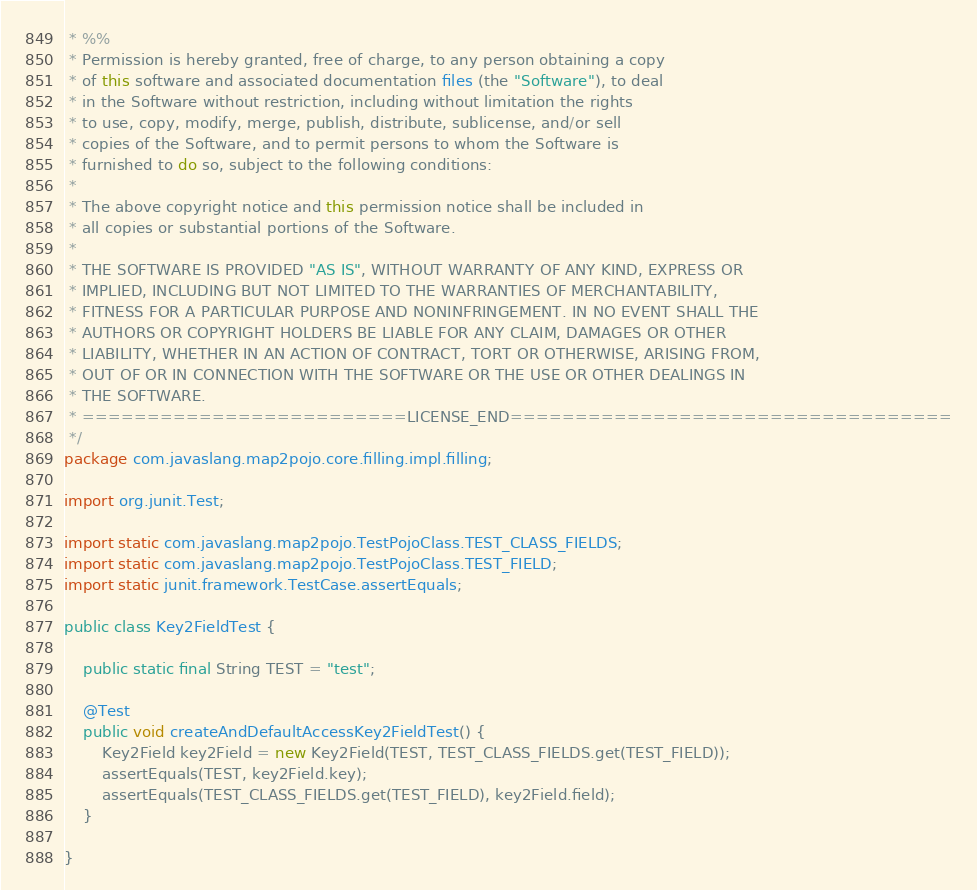Convert code to text. <code><loc_0><loc_0><loc_500><loc_500><_Java_> * %%
 * Permission is hereby granted, free of charge, to any person obtaining a copy
 * of this software and associated documentation files (the "Software"), to deal
 * in the Software without restriction, including without limitation the rights
 * to use, copy, modify, merge, publish, distribute, sublicense, and/or sell
 * copies of the Software, and to permit persons to whom the Software is
 * furnished to do so, subject to the following conditions:
 *
 * The above copyright notice and this permission notice shall be included in
 * all copies or substantial portions of the Software.
 *
 * THE SOFTWARE IS PROVIDED "AS IS", WITHOUT WARRANTY OF ANY KIND, EXPRESS OR
 * IMPLIED, INCLUDING BUT NOT LIMITED TO THE WARRANTIES OF MERCHANTABILITY,
 * FITNESS FOR A PARTICULAR PURPOSE AND NONINFRINGEMENT. IN NO EVENT SHALL THE
 * AUTHORS OR COPYRIGHT HOLDERS BE LIABLE FOR ANY CLAIM, DAMAGES OR OTHER
 * LIABILITY, WHETHER IN AN ACTION OF CONTRACT, TORT OR OTHERWISE, ARISING FROM,
 * OUT OF OR IN CONNECTION WITH THE SOFTWARE OR THE USE OR OTHER DEALINGS IN
 * THE SOFTWARE.
 * =========================LICENSE_END==================================
 */
package com.javaslang.map2pojo.core.filling.impl.filling;

import org.junit.Test;

import static com.javaslang.map2pojo.TestPojoClass.TEST_CLASS_FIELDS;
import static com.javaslang.map2pojo.TestPojoClass.TEST_FIELD;
import static junit.framework.TestCase.assertEquals;

public class Key2FieldTest {

    public static final String TEST = "test";

    @Test
    public void createAndDefaultAccessKey2FieldTest() {
        Key2Field key2Field = new Key2Field(TEST, TEST_CLASS_FIELDS.get(TEST_FIELD));
        assertEquals(TEST, key2Field.key);
        assertEquals(TEST_CLASS_FIELDS.get(TEST_FIELD), key2Field.field);
    }

}</code> 